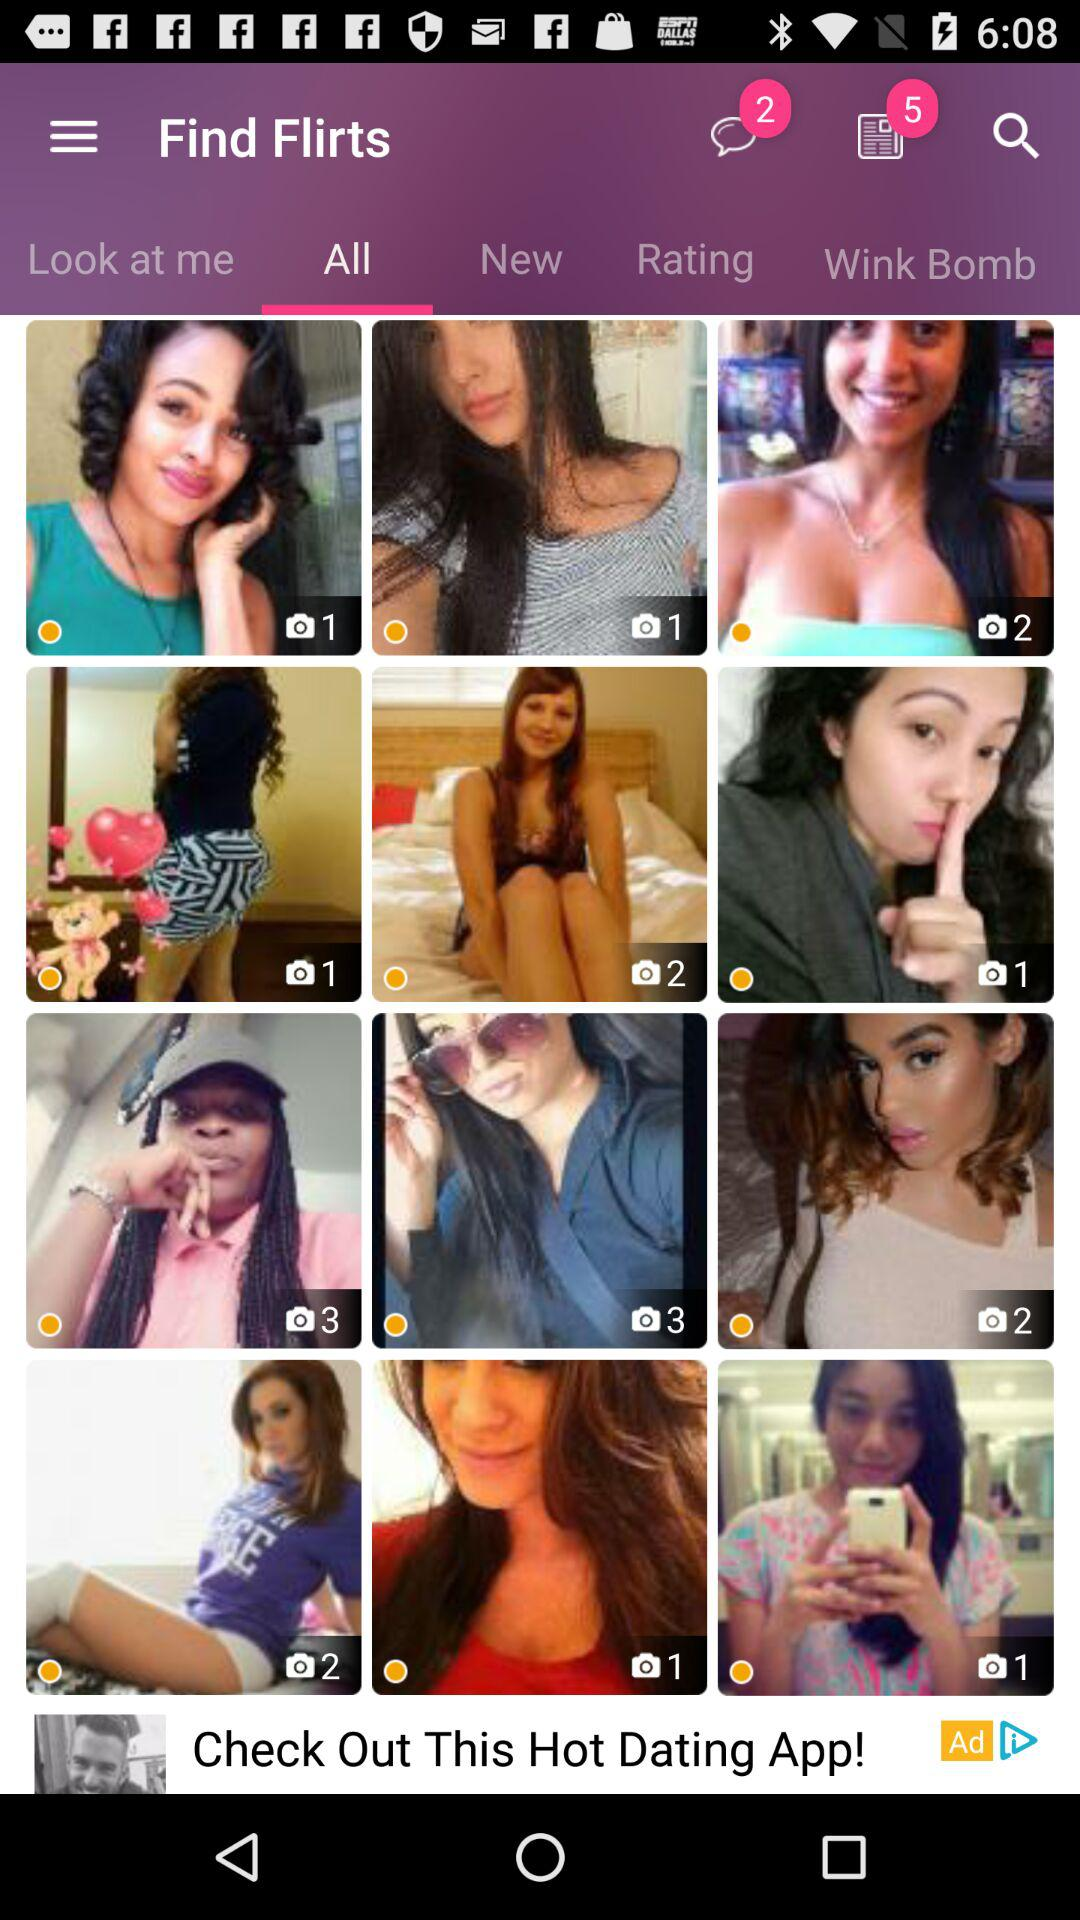How many unread messages are there? There are 2 unread messages. 